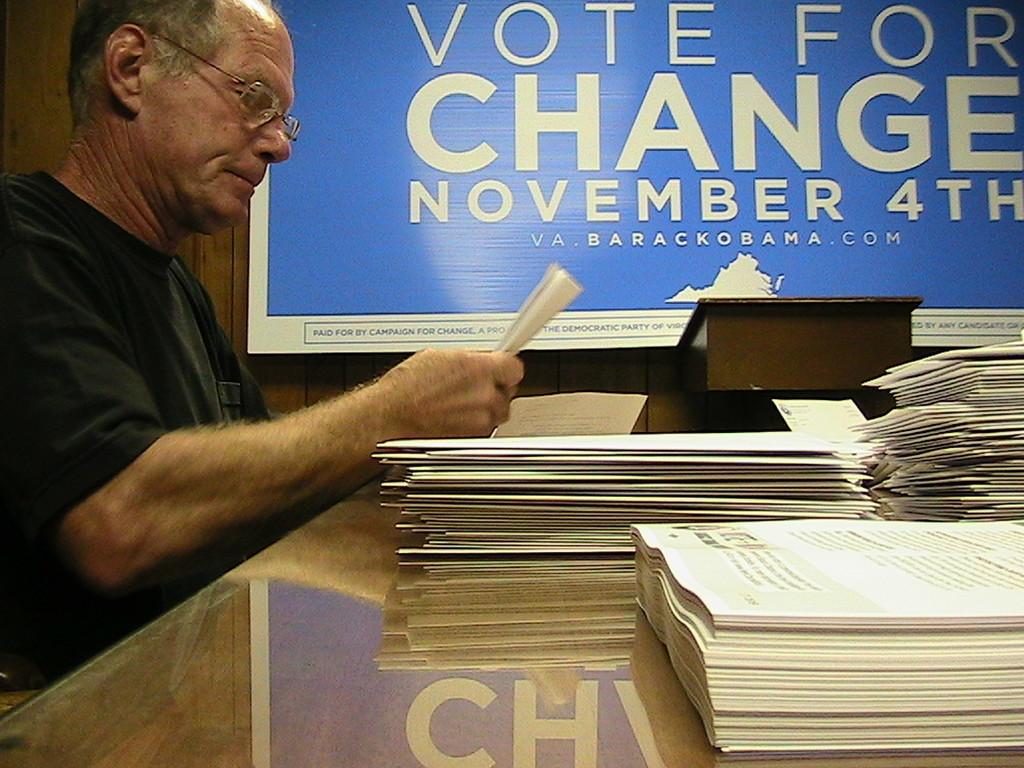When is the election?
Offer a terse response. November 4th. 